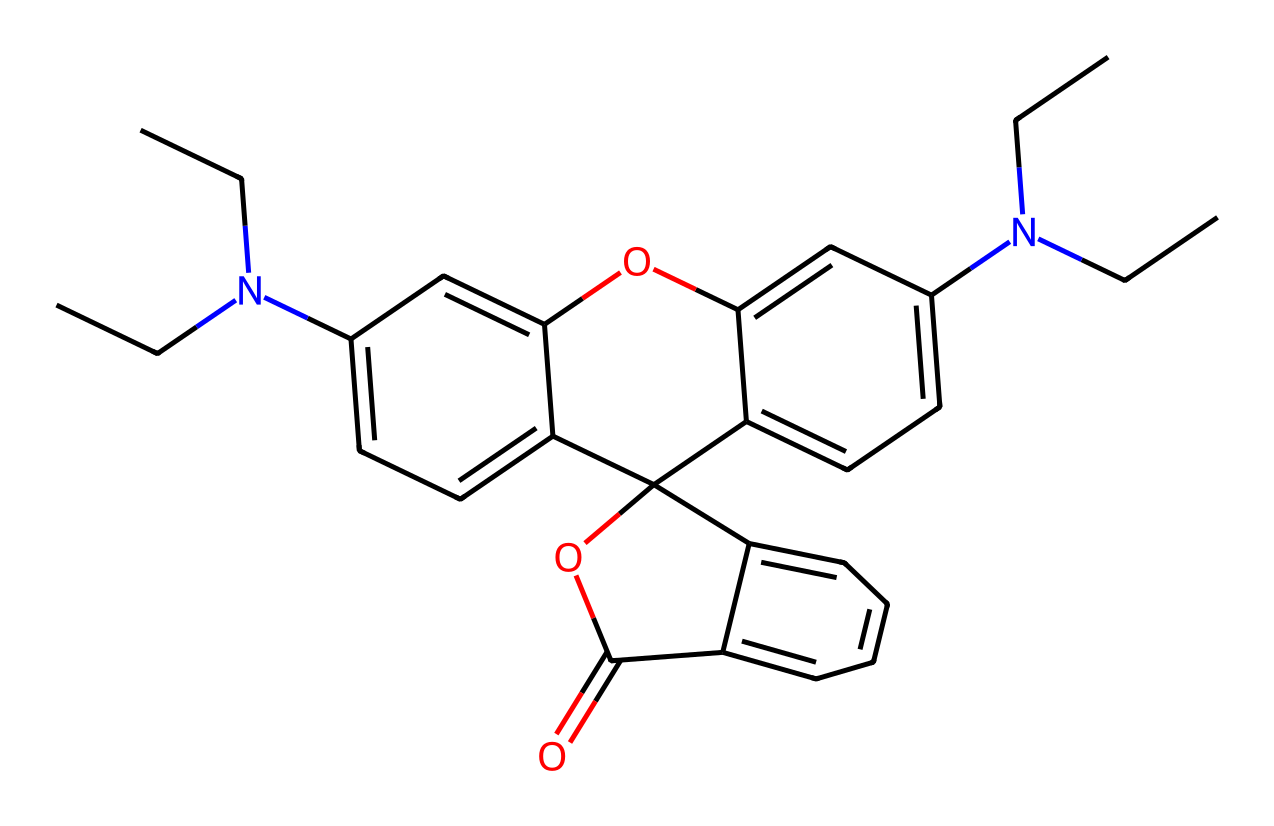What is the molecular formula of rhodamine B? To find the molecular formula, we need to identify the number and type of atoms represented in the SMILES. Upon analyzing the structure, the count of each type of atom is: Carbon (C) = 22, Hydrogen (H) = 24, Nitrogen (N) = 2, and Oxygen (O) = 3. This combines to give us the molecular formula: C22H24N2O3.
Answer: C22H24N2O3 How many nitrogen atoms are present in rhodamine B? By examining the SMILES structure, we can count the instances of nitrogen (N) in the formula. There are 2 distinct nitrogen atoms in the chemical's structure.
Answer: 2 What type of dye is rhodamine B classified as? Rhodamine B is a synthetic dye, primarily used in fluorescent applications. The structure includes a complex aromatic system, emphasizing its characteristic as a fluorescent dye.
Answer: fluorescent What functional groups are present in rhodamine B? The chemical structure includes several functional groups: an amine group (–N(CH2CH3)2) and an ester group (–C(=O)O). Identifying these functional groups reveals key functionalities of the dye.
Answer: amine and ester What is the primary use of rhodamine B in industry? Rhodamine B is commonly used in laser printing toners and other dye applications due to its vivid fluorescence and ability to absorb light. This makes it particularly valuable in printing and coloring processes.
Answer: laser printing toners How many rings are present in rhodamine B's structure? Examining the structure of rhodamine B indicated the presence of multiple interconnected aromatic rings. The complete structure contains three rings, making this dye quite complex.
Answer: 3 Is rhodamine B water-soluble? Given its ionic character and the presence of the amine and ester groups, rhodamine B possesses decent solubility in water. Analyzing the overall structure confirms its ability to interact with water molecules effectively.
Answer: yes 